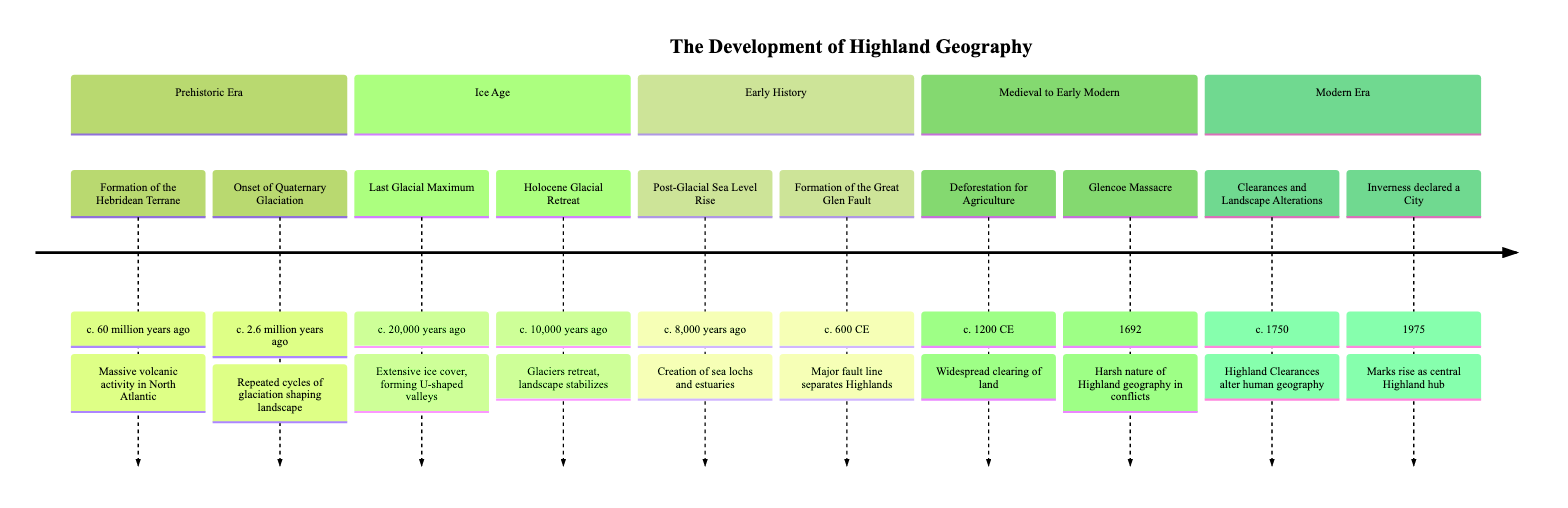What year does the Last Glacial Maximum occur? The diagram shows the event "Last Glacial Maximum" occurring around "c. 20,000 years ago." This is a clear indicator of the year associated with this specific event.
Answer: c. 20,000 years ago How many events are listed in the Modern Era section? In the diagram, the Modern Era section includes two events: "Clearances and Landscape Alterations" and "Inverness declared a City." Counting these events provides the answer.
Answer: 2 What major geological feature is formed around 600 CE? Looking at the diagram, the event "Formation of the Great Glen Fault" is explicitly mentioned as occurring around "c. 600 CE," which is the direct answer to the question.
Answer: Formation of the Great Glen Fault What event led to the creation of sea lochs and estuaries? The diagram identifies "Post-Glacial Sea Level Rise" as the event that led to this geographical feature around "c. 8,000 years ago," indicating the cause-and-effect relationship asked in the question.
Answer: Post-Glacial Sea Level Rise Which event directly follows the last glacial maximum? The event "Holocene Glacial Retreat" follows the "Last Glacial Maximum" as indicated in the timeline, since it occurs "c. 10,000 years ago," after the prior event at "c. 20,000 years ago." The sequential nature of the timeline clearly outlines this relationship.
Answer: Holocene Glacial Retreat What significant event associated with Highland conflicts happens in 1692? The diagram clearly states that the "Glencoe Massacre" occurred in "1692," specifically referencing its significance within the context of Highland geography and historical conflicts.
Answer: Glencoe Massacre What is a consequence of the Highland Clearances mentioned in the timeline? The event "Clearances and Landscape Alterations" indicates that the Highland Clearances led to "significant depopulation and changes in land use," which summarizes the consequence of this historical event as shown in the diagram.
Answer: Significant depopulation Identify the earliest glaciation event noted. The earliest glaciation event noted in the diagram is the "Onset of Quaternary Glaciation," which occurs around "c. 2.6 million years ago." This is the first mention of significant ice activity in the timeline.
Answer: Onset of Quaternary Glaciation What human activity is associated with the year c. 1200 CE? The diagram points to "Deforestation for Agricultural Expansion" occurring around "c. 1200 CE," marking it as a key human activity linked to that time period.
Answer: Deforestation for Agricultural Expansion 